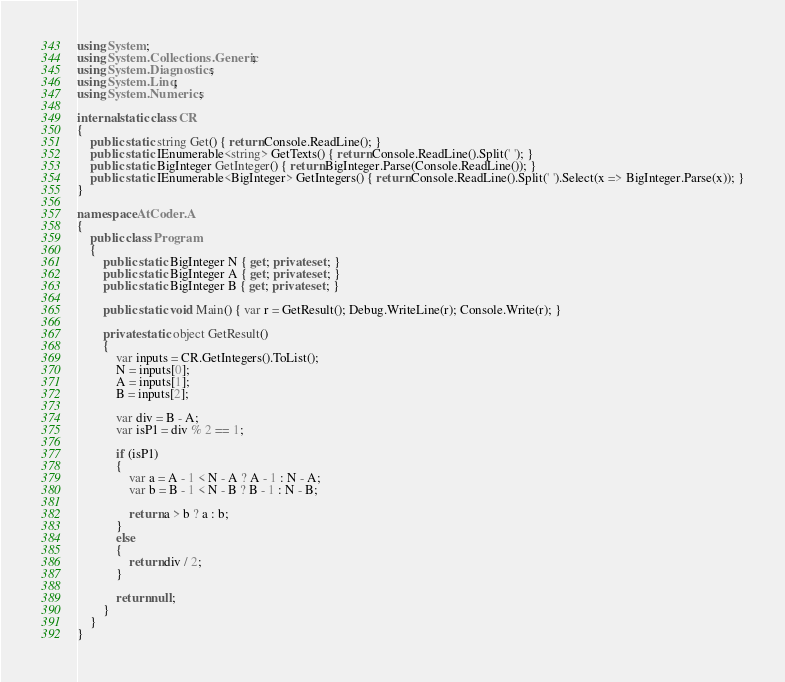<code> <loc_0><loc_0><loc_500><loc_500><_C#_>using System;
using System.Collections.Generic;
using System.Diagnostics;
using System.Linq;
using System.Numerics;

internal static class CR
{
    public static string Get() { return Console.ReadLine(); }
    public static IEnumerable<string> GetTexts() { return Console.ReadLine().Split(' '); }
    public static BigInteger GetInteger() { return BigInteger.Parse(Console.ReadLine()); }
    public static IEnumerable<BigInteger> GetIntegers() { return Console.ReadLine().Split(' ').Select(x => BigInteger.Parse(x)); }
}

namespace AtCoder.A
{
    public class Program
    {
        public static BigInteger N { get; private set; }
        public static BigInteger A { get; private set; }
        public static BigInteger B { get; private set; }

        public static void Main() { var r = GetResult(); Debug.WriteLine(r); Console.Write(r); }

        private static object GetResult()
        {
            var inputs = CR.GetIntegers().ToList();
            N = inputs[0];
            A = inputs[1];
            B = inputs[2];

            var div = B - A;
            var isP1 = div % 2 == 1;

            if (isP1)
            {
                var a = A - 1 < N - A ? A - 1 : N - A;
                var b = B - 1 < N - B ? B - 1 : N - B;

                return a > b ? a : b;
            }
            else
            {
                return div / 2;
            }

            return null;
        }
    }
}
</code> 